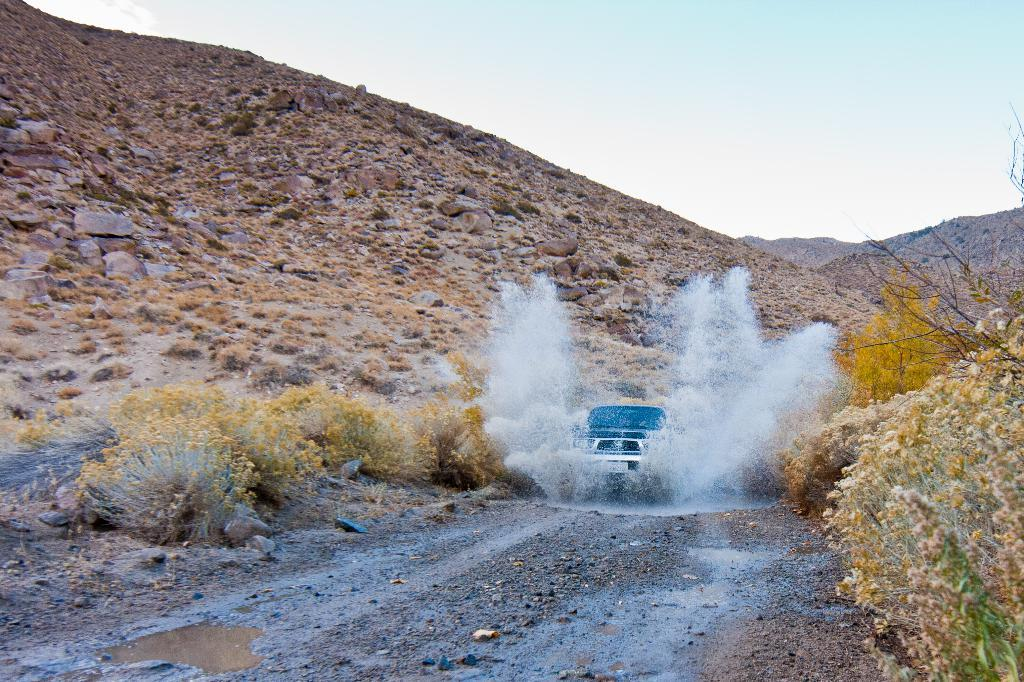What is the main subject in the center of the image? There is a vehicle in the center of the image. What can be seen in the image besides the vehicle? Water, hills, the sky, and plants are visible in the image. What type of terrain is visible in the background of the image? Hills are visible in the background of the image. What is visible in the sky in the image? The sky is visible in the background of the image. What type of zipper can be seen on the animal in the image? There is no animal or zipper present in the image. What type of oil is visible in the image? There is no oil visible in the image. 